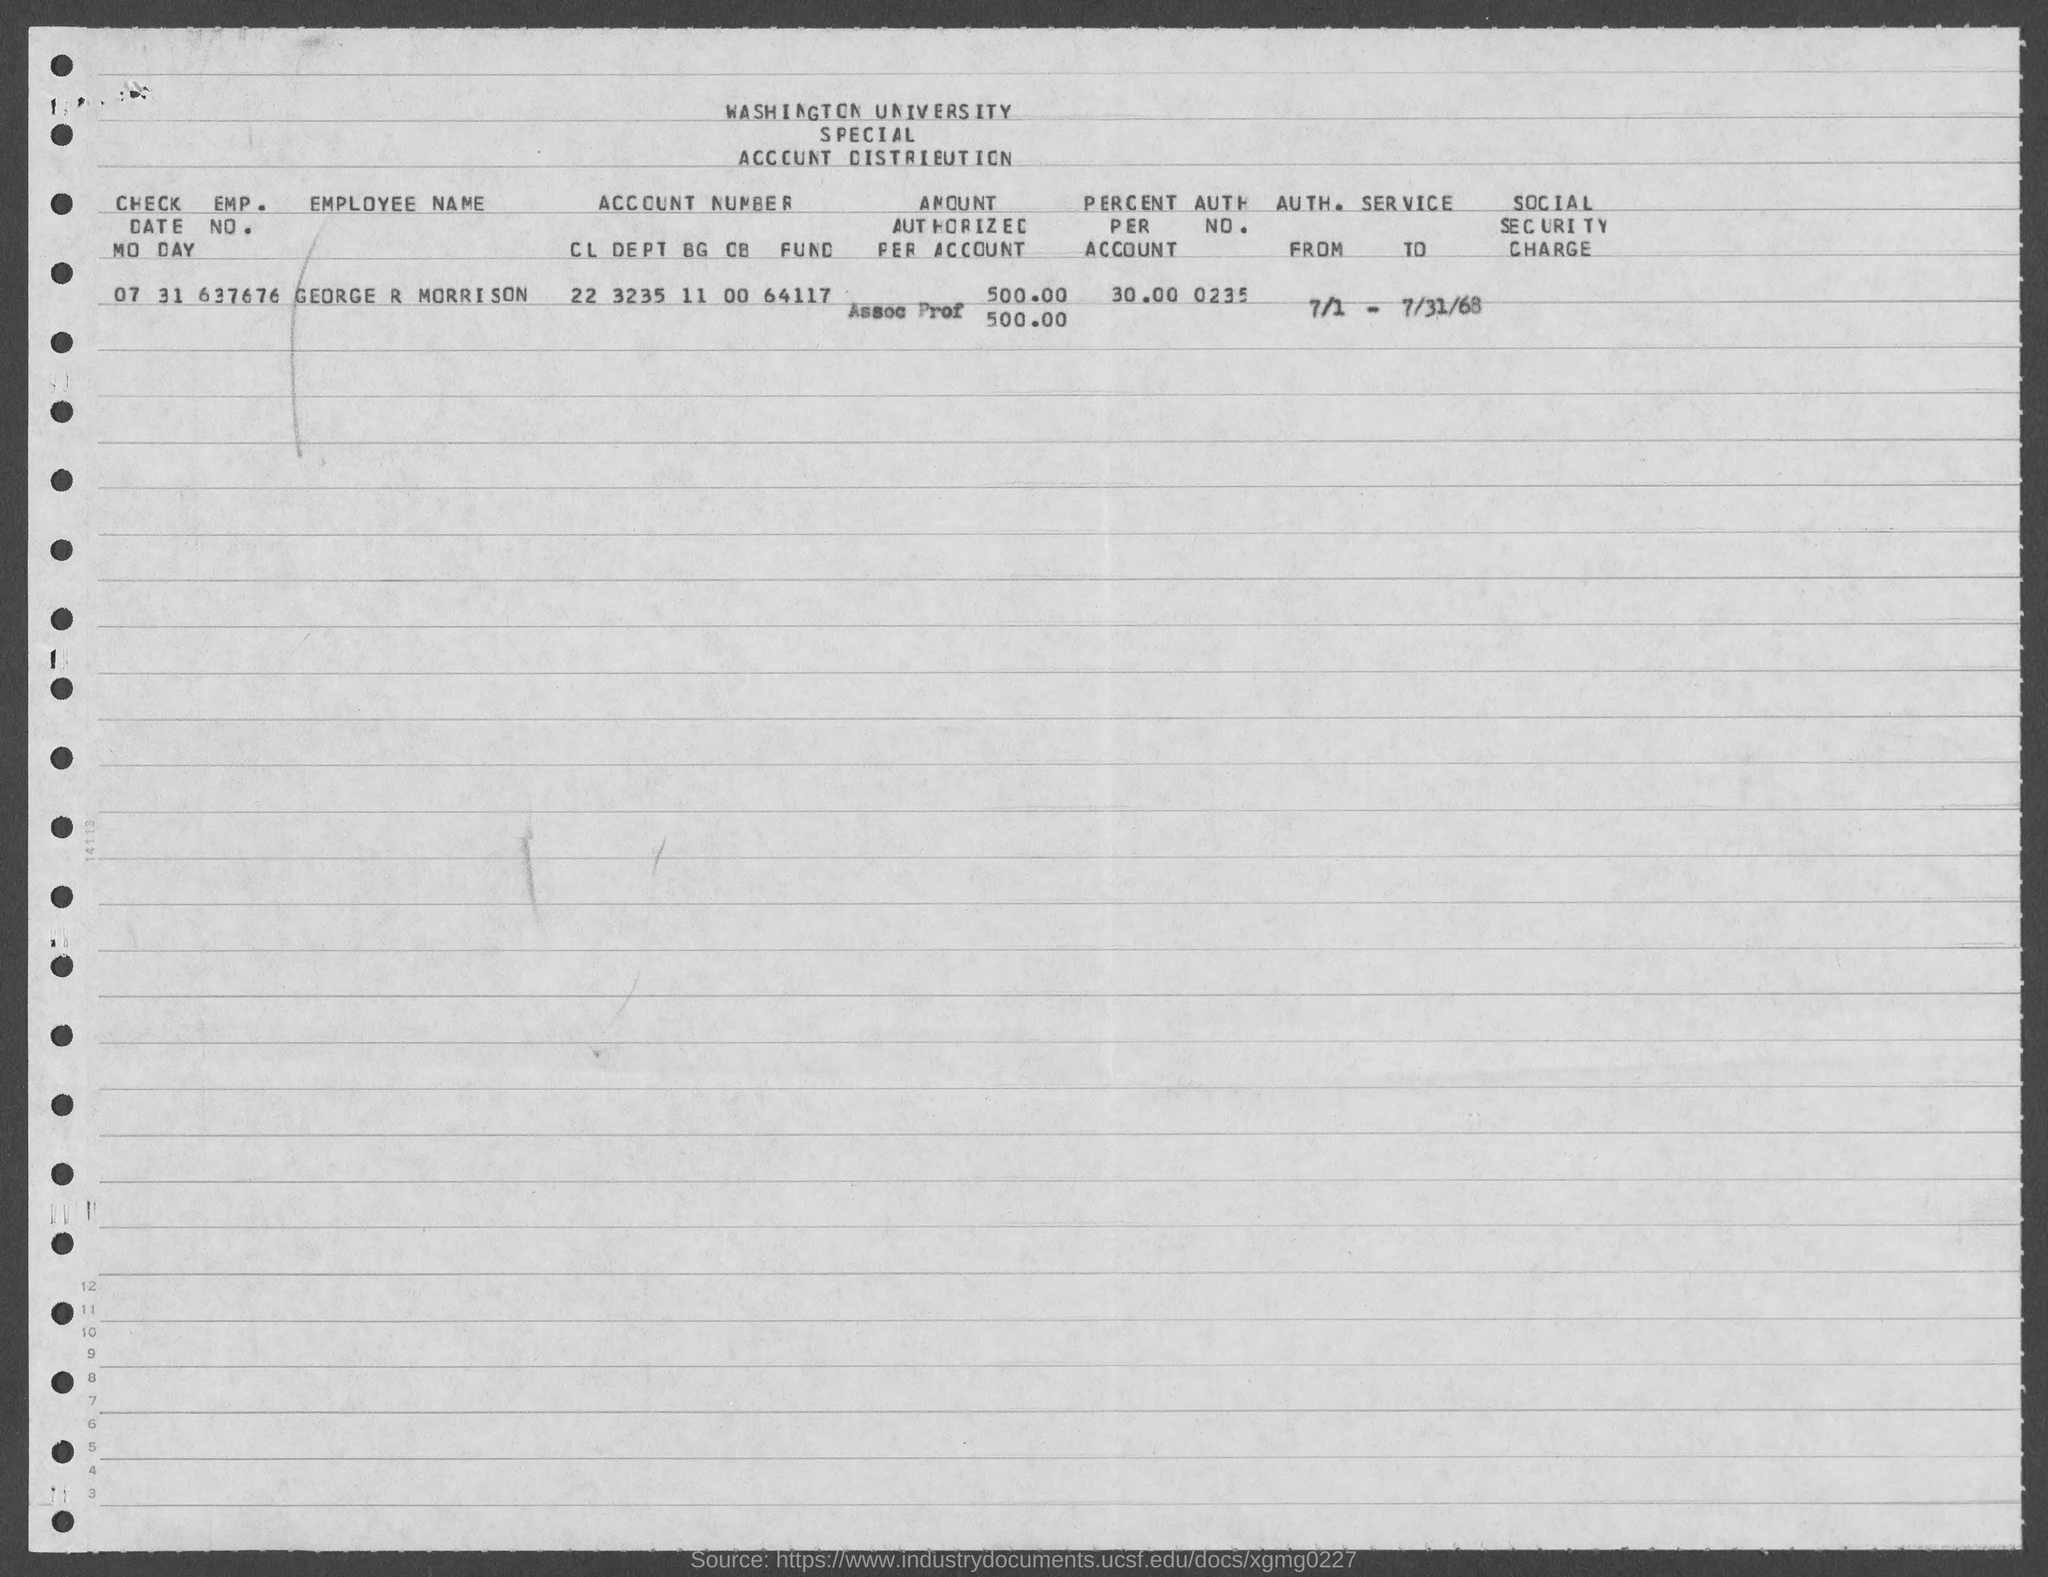What is the emp. no. of george r morrison ?
Ensure brevity in your answer.  637676. What is the percent per account of george r morrison ?
Provide a short and direct response. 30.00. What is the auth. no. of george r morrison ?
Make the answer very short. 0235. 